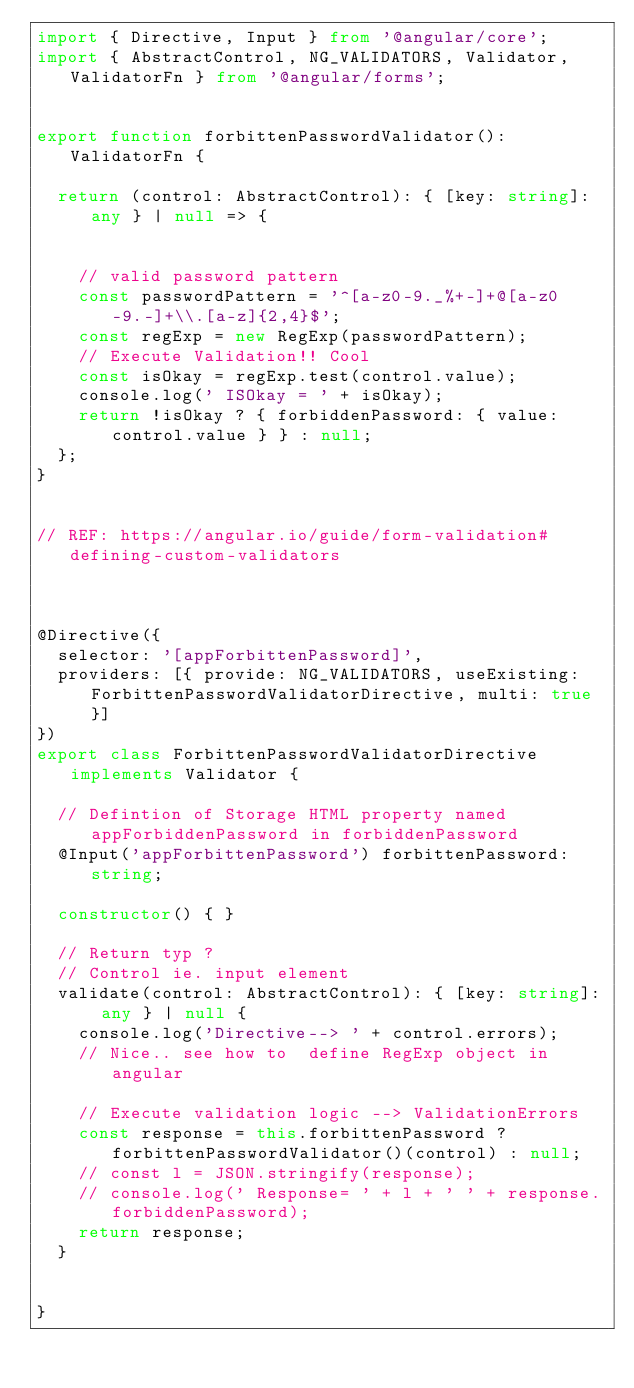<code> <loc_0><loc_0><loc_500><loc_500><_TypeScript_>import { Directive, Input } from '@angular/core';
import { AbstractControl, NG_VALIDATORS, Validator, ValidatorFn } from '@angular/forms';


export function forbittenPasswordValidator(): ValidatorFn {

  return (control: AbstractControl): { [key: string]: any } | null => {


    // valid password pattern
    const passwordPattern = '^[a-z0-9._%+-]+@[a-z0-9.-]+\\.[a-z]{2,4}$';
    const regExp = new RegExp(passwordPattern);
    // Execute Validation!! Cool
    const isOkay = regExp.test(control.value);
    console.log(' ISOkay = ' + isOkay);
    return !isOkay ? { forbiddenPassword: { value: control.value } } : null;
  };
}


// REF: https://angular.io/guide/form-validation#defining-custom-validators



@Directive({
  selector: '[appForbittenPassword]',
  providers: [{ provide: NG_VALIDATORS, useExisting: ForbittenPasswordValidatorDirective, multi: true }]
})
export class ForbittenPasswordValidatorDirective implements Validator {

  // Defintion of Storage HTML property named appForbiddenPassword in forbiddenPassword
  @Input('appForbittenPassword') forbittenPassword: string;

  constructor() { }

  // Return typ ?
  // Control ie. input element
  validate(control: AbstractControl): { [key: string]: any } | null {
    console.log('Directive--> ' + control.errors);
    // Nice.. see how to  define RegExp object in angular

    // Execute validation logic --> ValidationErrors
    const response = this.forbittenPassword ? forbittenPasswordValidator()(control) : null;
    // const l = JSON.stringify(response);
    // console.log(' Response= ' + l + ' ' + response.forbiddenPassword);
    return response;
  }


}
</code> 